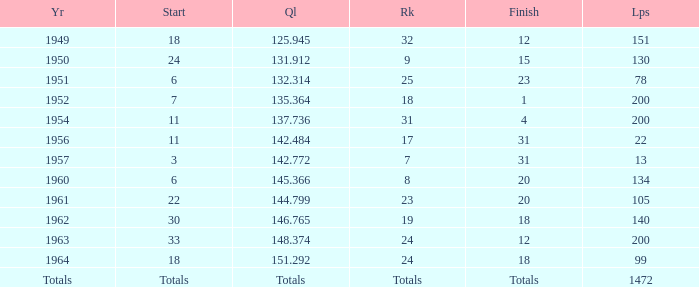Name the rank with laps of 200 and qual of 148.374 24.0. 